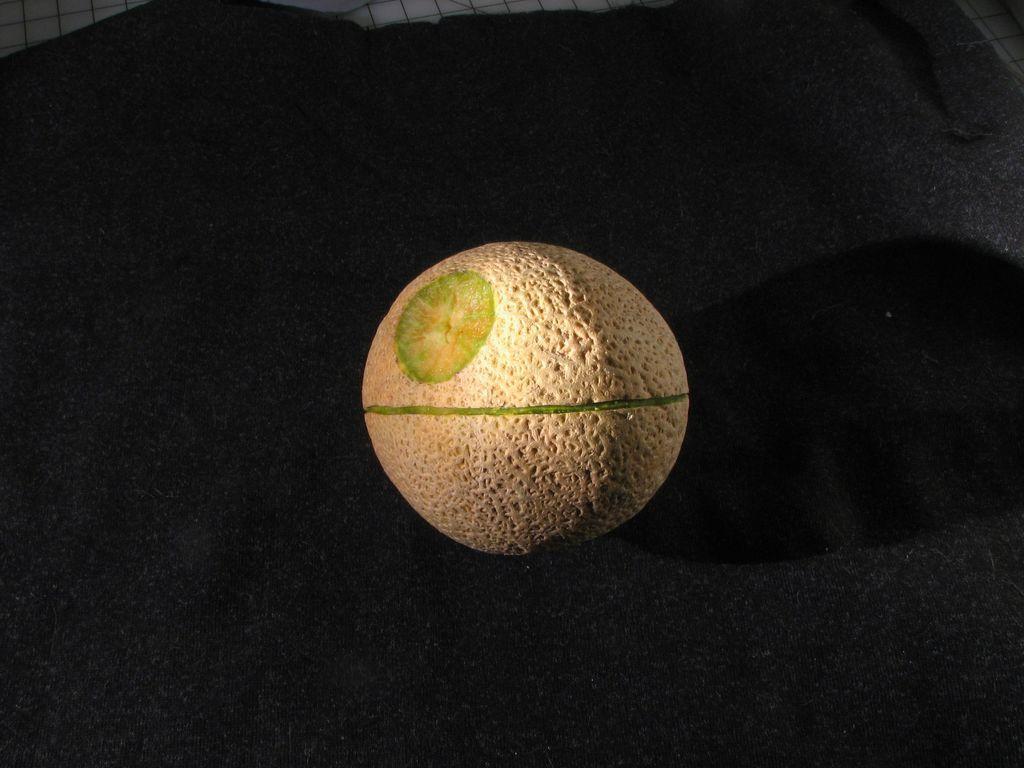In one or two sentences, can you explain what this image depicts? In this image I can see a round shaped object which has green color line on it. This object is on a black color surface. 